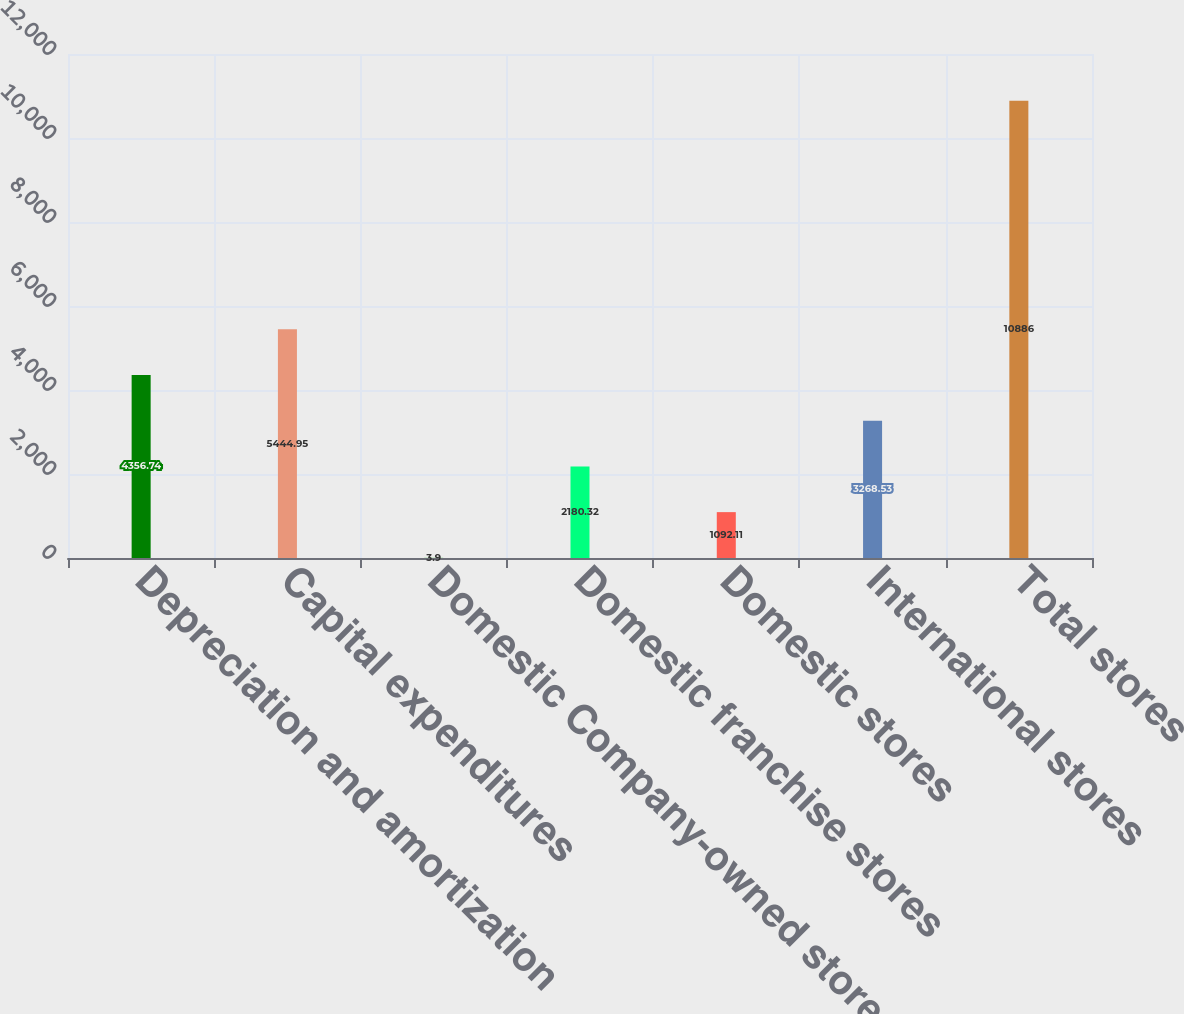Convert chart to OTSL. <chart><loc_0><loc_0><loc_500><loc_500><bar_chart><fcel>Depreciation and amortization<fcel>Capital expenditures<fcel>Domestic Company-owned stores<fcel>Domestic franchise stores<fcel>Domestic stores<fcel>International stores<fcel>Total stores<nl><fcel>4356.74<fcel>5444.95<fcel>3.9<fcel>2180.32<fcel>1092.11<fcel>3268.53<fcel>10886<nl></chart> 